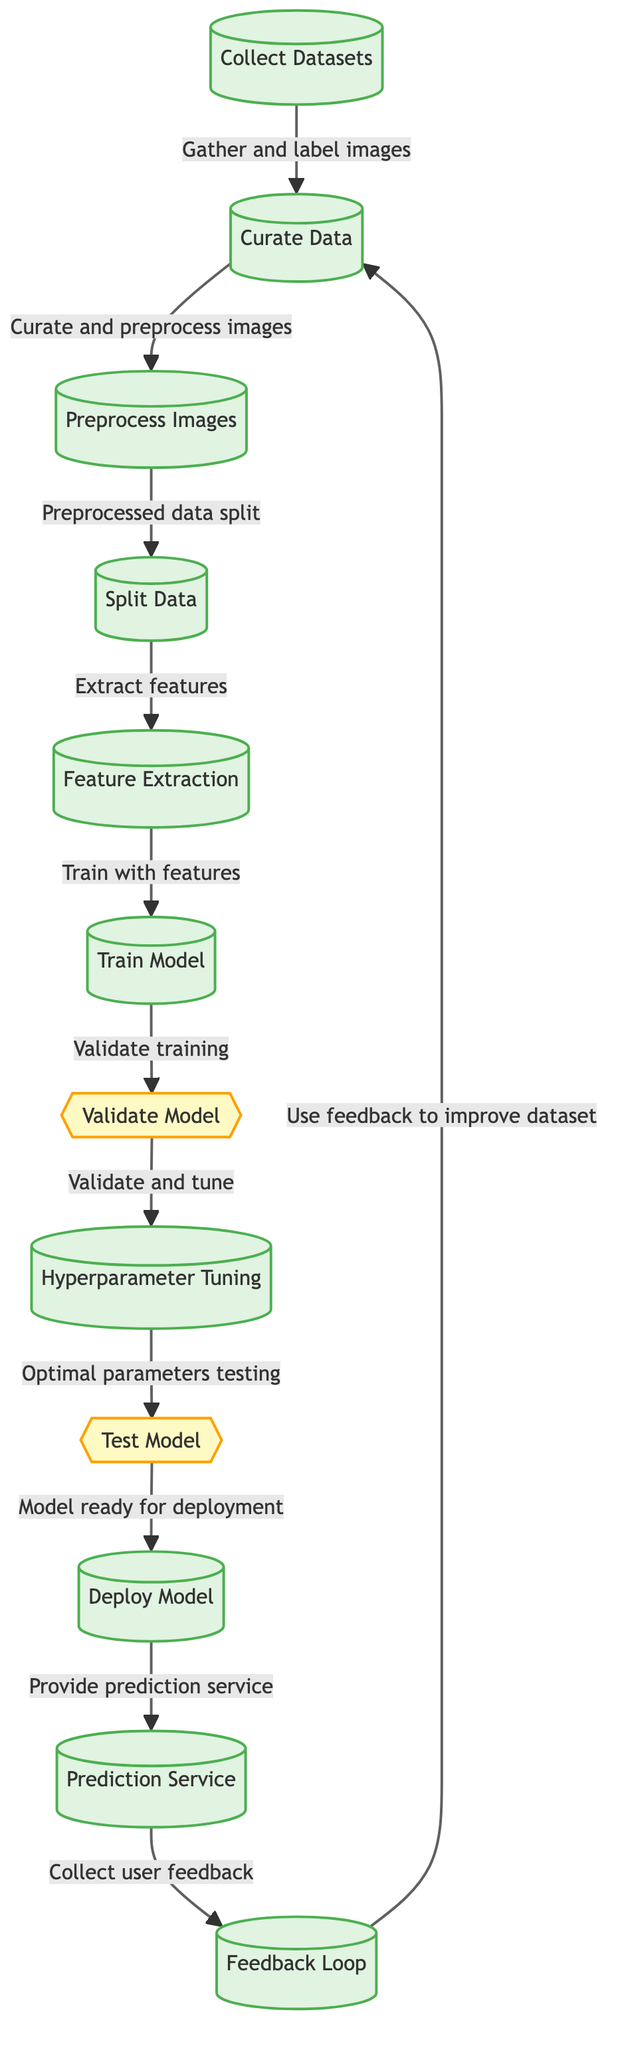What is the first step in the diagram? The first step in the diagram is labeled "Collect Datasets." This is the starting point from which the entire machine learning process begins, focusing on gathering the necessary images for classification.
Answer: Collect Datasets How many main processes are there in the diagram? By counting each process step represented as a node with a specific rectangle shape, there are a total of eight main processes outlined in the diagram.
Answer: Eight What action takes place after "Train Model"? After "Train Model," the next action is "Validate Model." This indicates that the model is assessed to ensure that it has been trained correctly before proceeding to further steps.
Answer: Validate Model Which step follows the hyperparameter tuning? Following "Hyperparameter Tuning," the next step is "Test Model." This indicates the process of evaluating the adjusted model's performance after tuning the hyperparameters.
Answer: Test Model What is the feedback loop connected to? The feedback loop is connected to the "Collect User Feedback" service. It allows for continuous improvement of the model by utilizing user feedback to refine the dataset.
Answer: Collect User Feedback How does the process flow after "Preprocess Images"? After "Preprocess Images," the process continues to "Split Data," indicating that once images are preprocessed, they are divided into separate sets for training and testing purposes.
Answer: Split Data What happens when the model is validated successfully? When the model is validated successfully, it leads to the "Hyperparameter Tuning" step, indicating that adjustments are made to fine-tune the model's parameters for optimal performance.
Answer: Hyperparameter Tuning Which two steps are decision points in the diagram? The decision points in the diagram are "Validate Model" and "Test Model." Each of these points requires verification of the preceding processes to determine the next steps.
Answer: Validate Model and Test Model What service is provided after deploying the model? After deploying the model, the service provided is the "Prediction Service." This step involves making classifications based on the trained model's outputs.
Answer: Prediction Service 